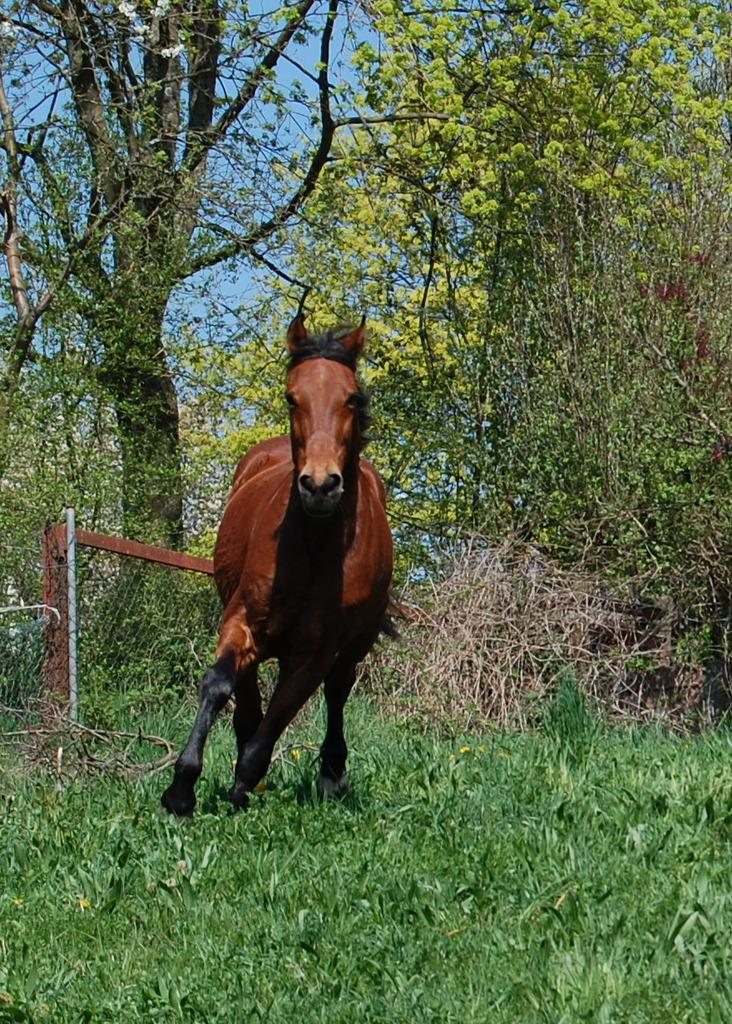What animal can be seen in the image? There is a horse in the image. What is the horse doing in the image? The horse is moving. What colors can be seen on the horse? The horse is brown and black in color. What type of vegetation is visible in the image? There are trees visible in the image. What is the ground covered with in the image? There is grass on the ground in the image. What color is the sky in the image? The sky is blue. What type of bread can be seen in the image? There is no bread present in the image; it features a horse moving in a grassy area with trees and a blue sky. 